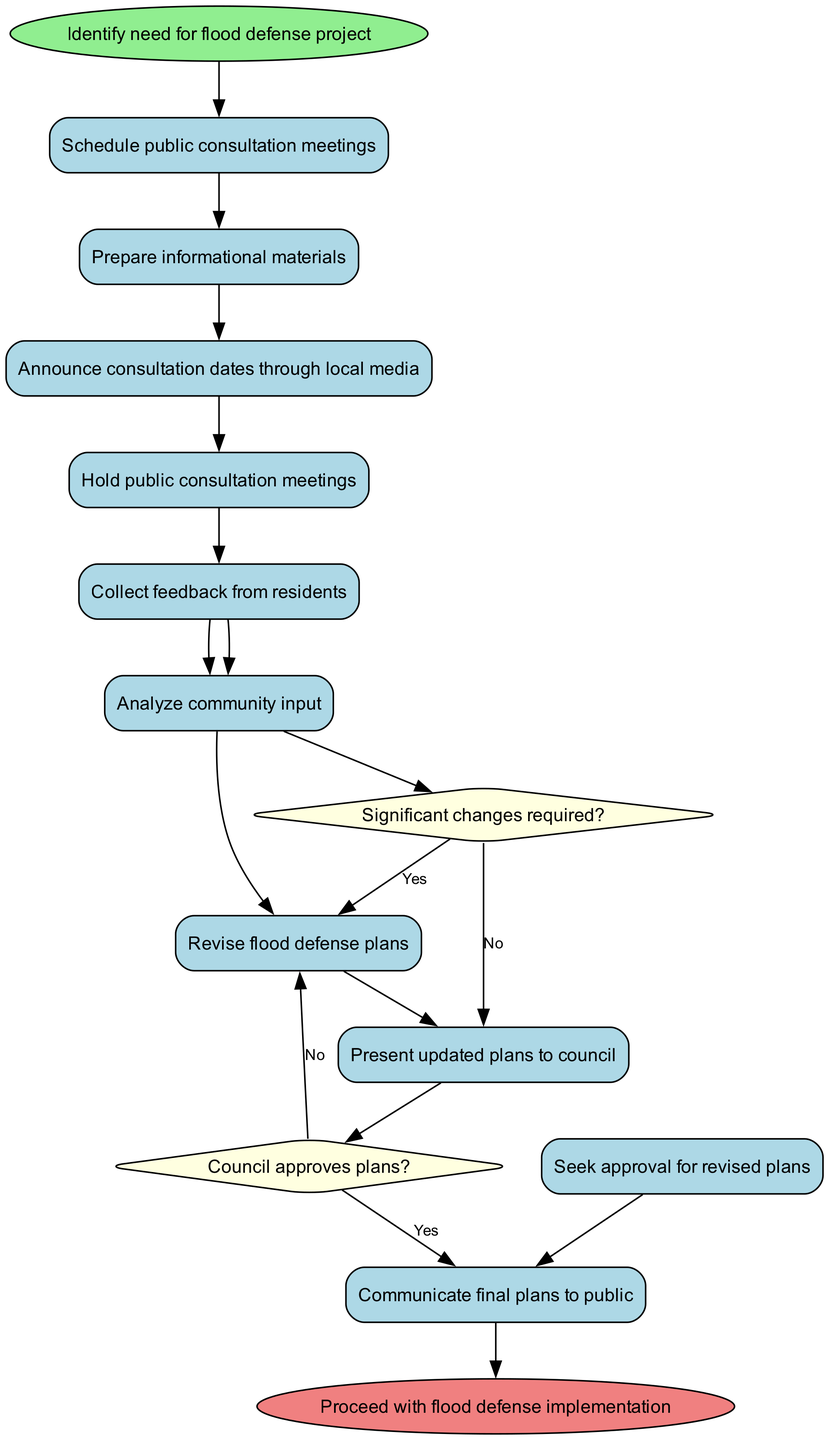What is the first activity in the diagram? The first activity follows the start node. The start node mentions "Identify need for flood defense project," and immediately after, the first activity is "Schedule public consultation meetings."
Answer: Schedule public consultation meetings How many activities are listed in the diagram? The diagram contains a total of 10 activities, including the first one and the last one. Each is individually listed.
Answer: 10 What is the decision question that follows "Hold public consultation meetings"? After "Hold public consultation meetings," the next step is to gather feedback, leading into the decision node asking "Significant changes required?"
Answer: Significant changes required? What happens if the council does not approve the plans? If the council does not approve the plans, the flow returns to "Revise flood defense plans" according to the diagram structure that shows the decision "Council approves plans?" and its "No" path.
Answer: Revise flood defense plans How many edges connect the activities? To determine the number of edges between activities, trace each directed line between nodes in the diagram. There are a total of 9 edges connecting the activities.
Answer: 9 What activity follows the collection of feedback from residents? After "Collect feedback from residents," the next activity is "Analyze community input," showing the sequential process of handling feedback.
Answer: Analyze community input What activity occurs immediately after "Present updated plans to council"? The activity that follows "Present updated plans to council" is a decision to be made, specifically "Council approves plans?" according to the flow of activities.
Answer: Council approves plans? What occurs if significant changes are required? If significant changes are required, the diagram indicates that the process returns to "Revise flood defense plans," reiterating that revisions must be made before proceeding.
Answer: Revise flood defense plans How is the final step in the diagram described? The final step in the diagram concludes with the end node, which states, "Proceed with flood defense implementation," denoting the successful completion of the process.
Answer: Proceed with flood defense implementation 